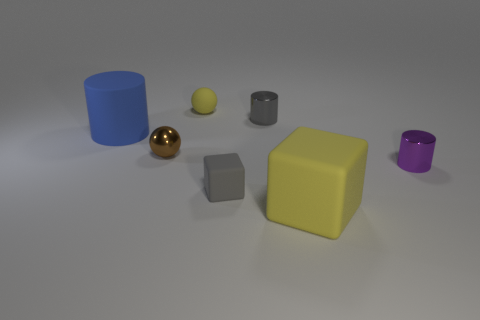Add 2 big cylinders. How many objects exist? 9 Subtract all spheres. How many objects are left? 5 Subtract 1 blue cylinders. How many objects are left? 6 Subtract all large blue rubber cylinders. Subtract all metal balls. How many objects are left? 5 Add 2 brown balls. How many brown balls are left? 3 Add 2 tiny metallic objects. How many tiny metallic objects exist? 5 